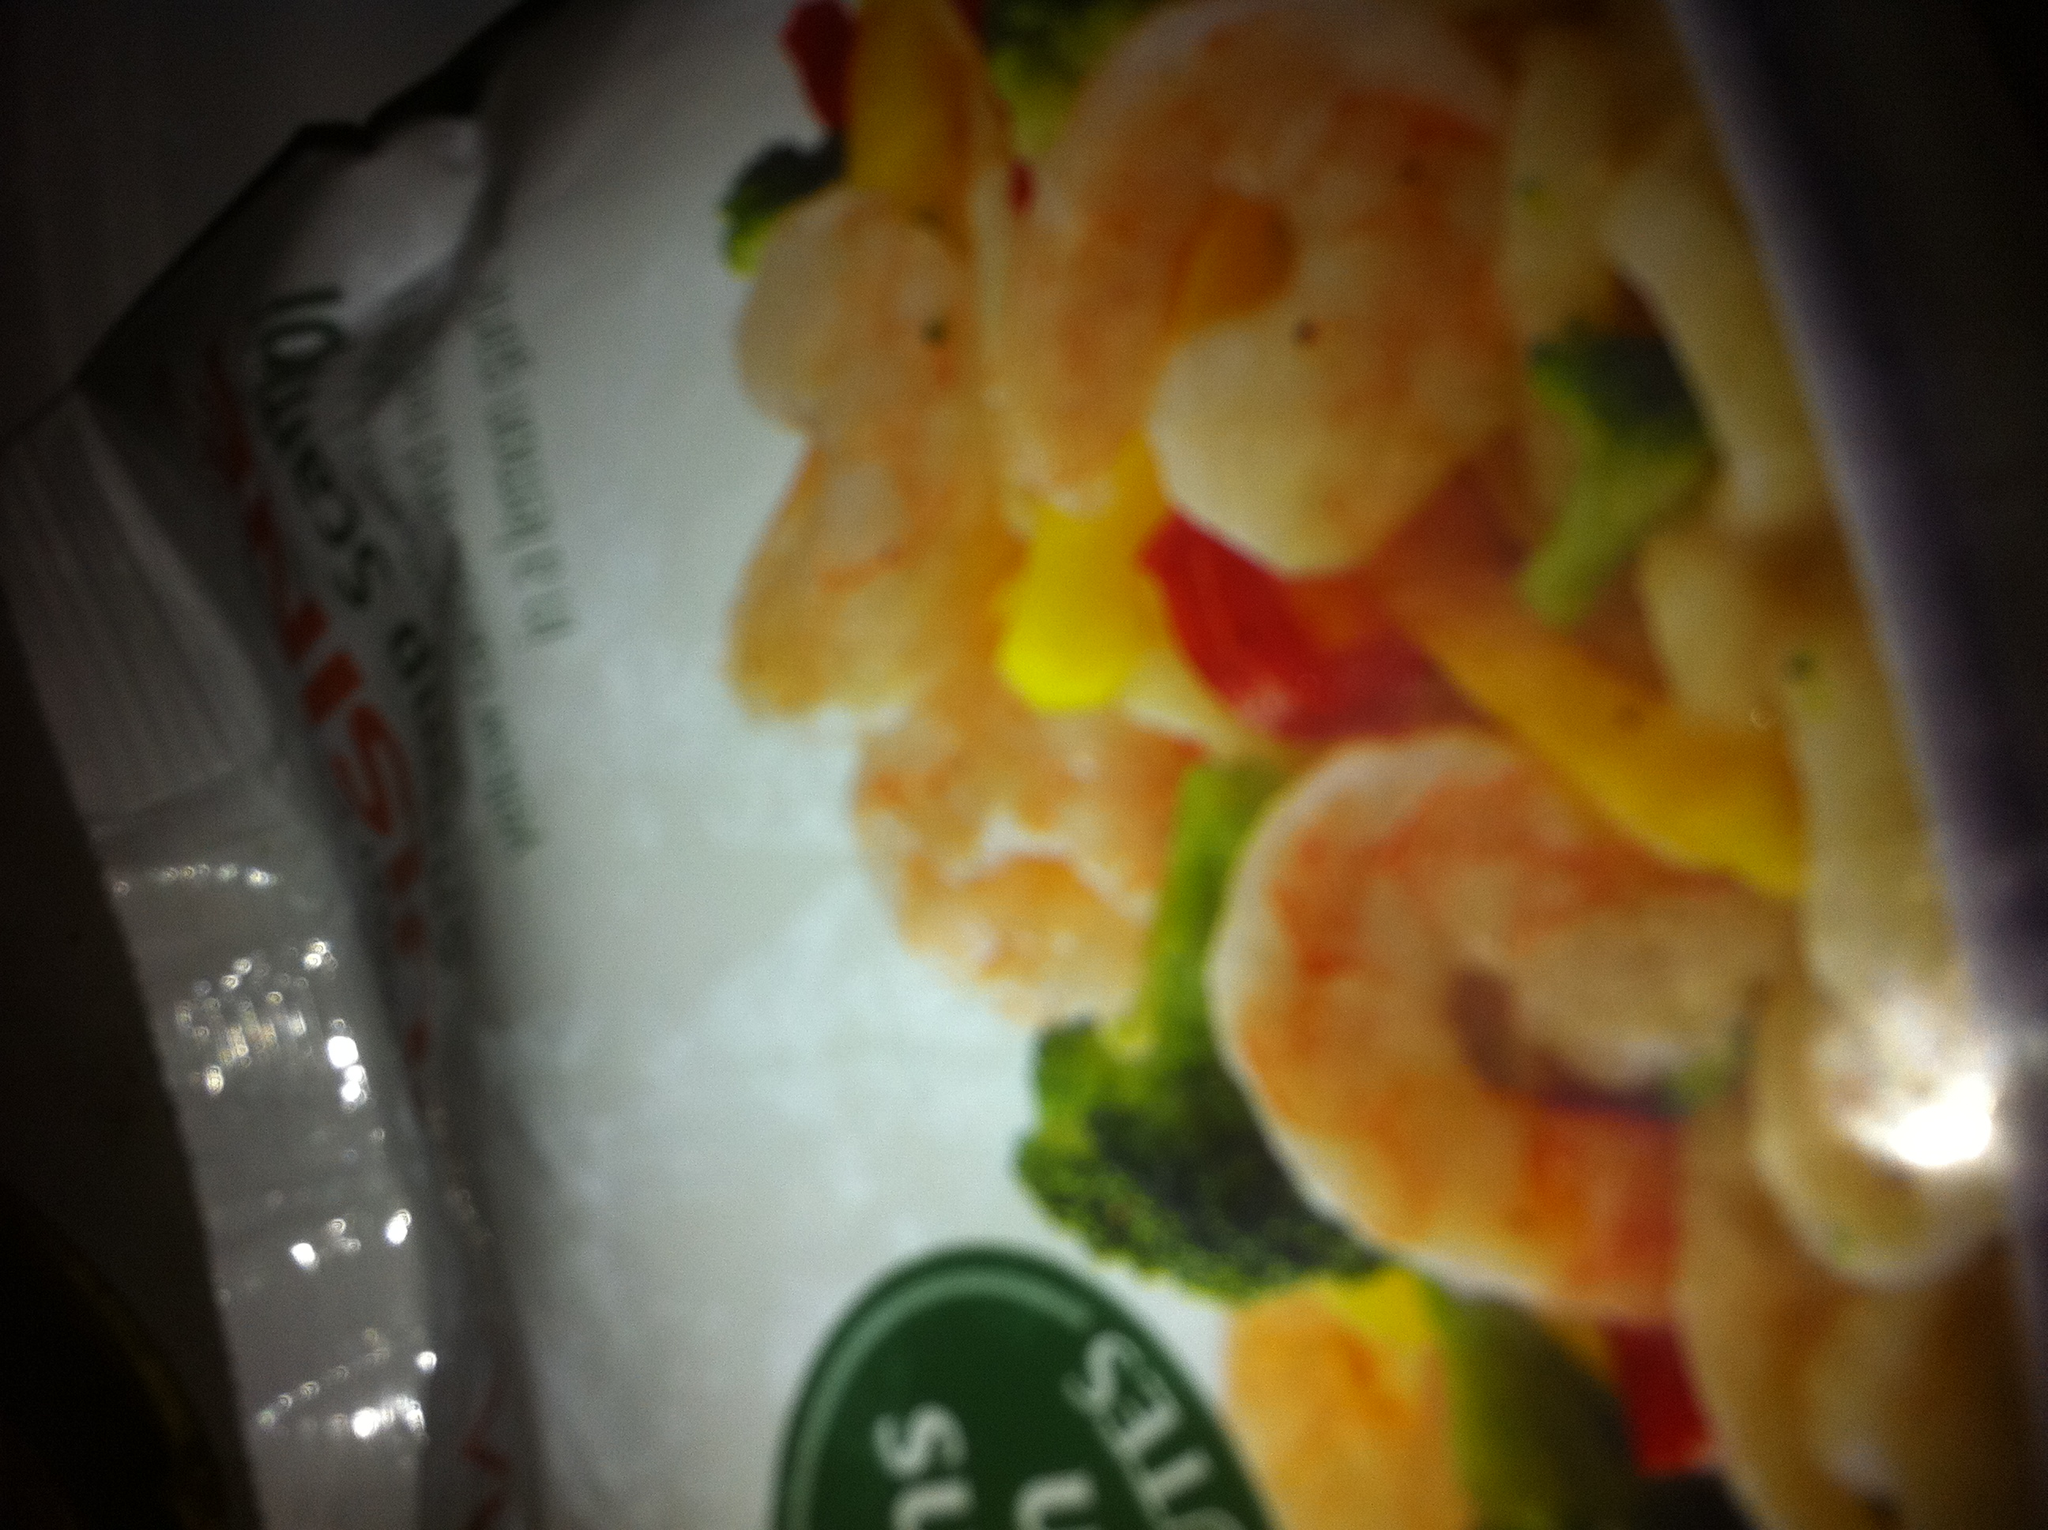What is this? This is a dish featuring shrimp and mixed vegetables, likely intended as a healthy, flavorful meal option. The shrimp appear to be cooked and possibly seasoned, mixed with an array of vegetables such as broccoli and bell peppers. This combination suggests a focus on providing a balanced and nutritious meal, often found in pre-packaged frozen dinner options. 